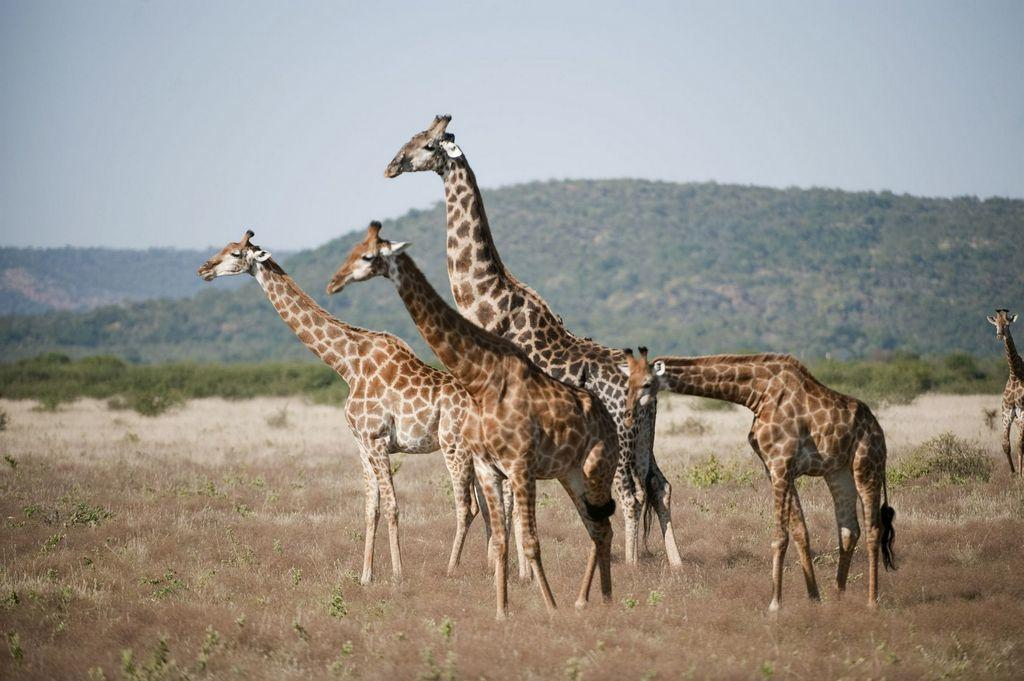What animals are in the center of the image? There are giraffes in the center of the image. What can be found on the ground in the image? There are plants and dry grass on the ground. What is visible in the background of the image? There are trees in the background of the image. How would you describe the sky in the image? The sky is cloudy in the image. Where are the cherries hanging from in the image? There are no cherries present in the image. Can you see a goose or a donkey in the image? No, there are no geese or donkeys visible in the image. 